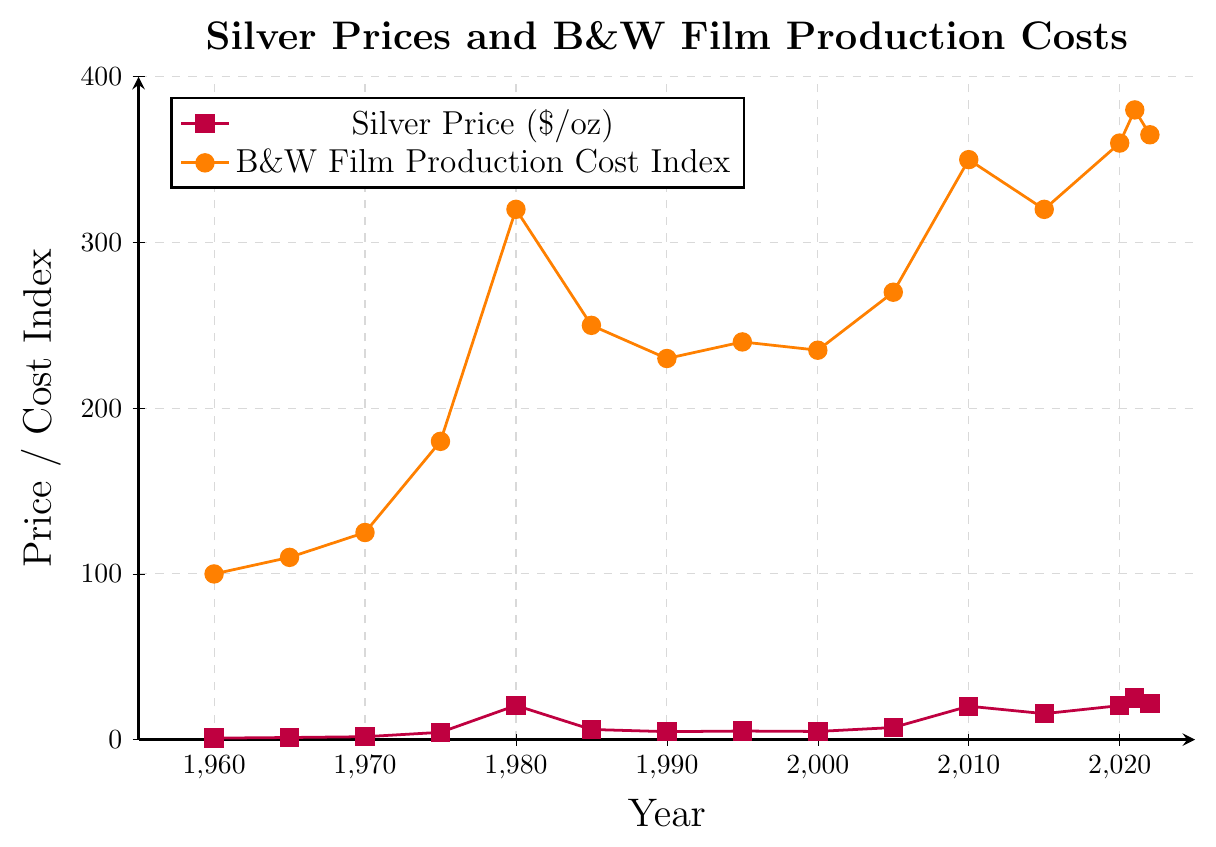Which year had the highest silver price? By checking the maximum value along the purple curve for silver prices, the highest point appears in the year 2021 with a value of $25.14 per ounce.
Answer: 2021 How did the Black and White Film Production Cost Index change from 1960 to 1980? In 1960, the cost index was 100, and in 1980, it was 320. To find the change, subtract 100 from 320, resulting in an increase of 220.
Answer: Increased by 220 What is the relationship between silver prices and the Black and White Film Production Cost Index in the year 1985? In 1985, the silver price was $6.14 per ounce, and the cost index was 250. Both values reflect a drop from their previous highs in 1980 but do not reach their former lows. This indicates a correlation where both values decrease relatively.
Answer: Both decreased In which years did the silver price exceed $20 per ounce? The purple curve crosses $20 per ounce in the years 1980, 2010, 2020, 2021, and 2022.
Answer: 1980, 2010, 2020, 2021, 2022 What was the approximate difference in the Black and White Film Production Cost Index between 2010 and 2022? In 2010, the cost index was 350, while in 2022, it was 365. To find the difference, subtract 350 from 365, resulting in 15.
Answer: 15 How did the silver price trend from 2000 to 2010? Observing the purple curve from 2000 ($4.95) to 2005 ($7.32) and then to 2010 ($20.19), silver prices clearly exhibit an upward trend.
Answer: Increased Compare the Black and White Film Production Cost Index in 1990 and 1995. In 1990, the cost index was 230, and in 1995, it was 240. There is a rise of 10 units in the cost index over this period.
Answer: 1995 was higher by 10 Was the silver price higher in 1985 or in 2005? The silver price in 1985 was $6.14, while in 2005, it was $7.32. Comparing these prices, 2005 had the higher silver price.
Answer: 2005 Describe the visual differences in the trends of the purple line and the orange line. The purple line for silver prices has more dramatic fluctuations, showing peaks and troughs, while the orange line for the cost index has a more gradual, consistent upward trend with minor fluctuations.
Answer: Silver prices fluctuate more dramatically, whereas the cost index trends more steadily upward 